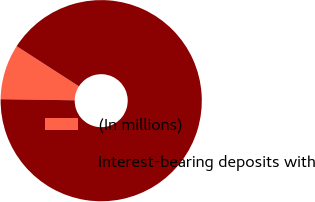Convert chart to OTSL. <chart><loc_0><loc_0><loc_500><loc_500><pie_chart><fcel>(In millions)<fcel>Interest-bearing deposits with<nl><fcel>8.87%<fcel>91.13%<nl></chart> 